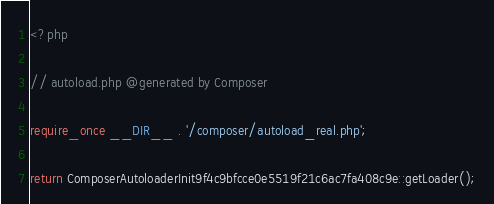<code> <loc_0><loc_0><loc_500><loc_500><_PHP_><?php

// autoload.php @generated by Composer

require_once __DIR__ . '/composer/autoload_real.php';

return ComposerAutoloaderInit9f4c9bfcce0e5519f21c6ac7fa408c9e::getLoader();
</code> 